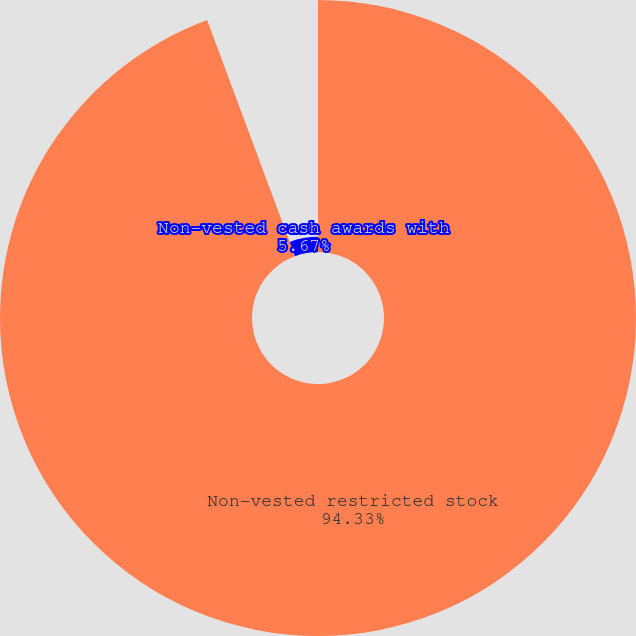<chart> <loc_0><loc_0><loc_500><loc_500><pie_chart><fcel>Non-vested restricted stock<fcel>Non-vested cash awards with<nl><fcel>94.33%<fcel>5.67%<nl></chart> 